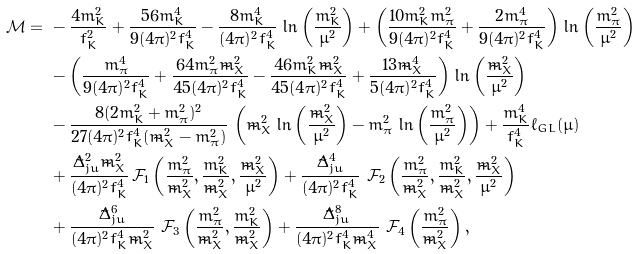<formula> <loc_0><loc_0><loc_500><loc_500>\mathcal { M } = & \ - \frac { 4 m _ { K } ^ { 2 } } { f _ { K } ^ { 2 } } + \frac { 5 6 m _ { K } ^ { 4 } } { 9 ( 4 \pi ) ^ { 2 } f _ { K } ^ { 4 } } - \frac { 8 m _ { K } ^ { 4 } } { ( 4 \pi ) ^ { 2 } f _ { K } ^ { 4 } } \, \ln \left ( \frac { m _ { K } ^ { 2 } } { \mu ^ { 2 } } \right ) + \left ( \frac { 1 0 m _ { K } ^ { 2 } m _ { \pi } ^ { 2 } } { 9 ( 4 \pi ) ^ { 2 } f _ { K } ^ { 4 } } + \frac { 2 m _ { \pi } ^ { 4 } } { 9 ( 4 \pi ) ^ { 2 } f _ { K } ^ { 4 } } \right ) \, \ln \left ( \frac { m _ { \pi } ^ { 2 } } { \mu ^ { 2 } } \right ) \\ & \ - \left ( \frac { m _ { \pi } ^ { 4 } } { 9 ( 4 \pi ) ^ { 2 } f _ { K } ^ { 4 } } + \frac { 6 4 m _ { \pi } ^ { 2 } \tilde { m } _ { X } ^ { 2 } } { 4 5 ( 4 \pi ) ^ { 2 } f _ { K } ^ { 4 } } - \frac { 4 6 m _ { K } ^ { 2 } \tilde { m } _ { X } ^ { 2 } } { 4 5 ( 4 \pi ) ^ { 2 } f _ { K } ^ { 4 } } + \frac { 1 3 \tilde { m } _ { X } ^ { 4 } } { 5 ( 4 \pi ) ^ { 2 } f _ { K } ^ { 4 } } \right ) \, \ln \left ( \frac { \tilde { m } _ { X } ^ { 2 } } { \mu ^ { 2 } } \right ) \\ & \ - \frac { 8 ( 2 m _ { K } ^ { 2 } + m _ { \pi } ^ { 2 } ) ^ { 2 } } { 2 7 ( 4 \pi ) ^ { 2 } f _ { K } ^ { 4 } ( \tilde { m } _ { X } ^ { 2 } - m _ { \pi } ^ { 2 } ) } \, \left ( \tilde { m } _ { X } ^ { 2 } \, \ln \left ( \frac { \tilde { m } _ { X } ^ { 2 } } { \mu ^ { 2 } } \right ) - m _ { \pi } ^ { 2 } \, \ln \left ( \frac { m _ { \pi } ^ { 2 } } { \mu ^ { 2 } } \right ) \right ) + \frac { m _ { K } ^ { 4 } } { f _ { K } ^ { 4 } } \ell _ { G L } ( \mu ) \\ & \ + \frac { \tilde { \Delta } _ { j u } ^ { 2 } \tilde { m } _ { X } ^ { 2 } } { ( 4 \pi ) ^ { 2 } f _ { K } ^ { 4 } } \, \mathcal { F } _ { 1 } \left ( \frac { m _ { \pi } ^ { 2 } } { \tilde { m } _ { X } ^ { 2 } } , \frac { m _ { K } ^ { 2 } } { \tilde { m } _ { X } ^ { 2 } } , \frac { \tilde { m } _ { X } ^ { 2 } } { \mu ^ { 2 } } \right ) + \frac { \tilde { \Delta } _ { j u } ^ { 4 } } { ( 4 \pi ) ^ { 2 } f _ { K } ^ { 4 } } \ \mathcal { F } _ { 2 } \left ( \frac { m _ { \pi } ^ { 2 } } { \tilde { m } _ { X } ^ { 2 } } , \frac { m _ { K } ^ { 2 } } { \tilde { m } _ { X } ^ { 2 } } , \frac { \tilde { m } _ { X } ^ { 2 } } { \mu ^ { 2 } } \right ) \\ & \ + \frac { \tilde { \Delta } _ { j u } ^ { 6 } } { ( 4 \pi ) ^ { 2 } f _ { K } ^ { 4 } \tilde { m } _ { X } ^ { 2 } } \ \mathcal { F } _ { 3 } \left ( \frac { m _ { \pi } ^ { 2 } } { \tilde { m } _ { X } ^ { 2 } } , \frac { m _ { K } ^ { 2 } } { \tilde { m } _ { X } ^ { 2 } } \right ) + \frac { \tilde { \Delta } _ { j u } ^ { 8 } } { ( 4 \pi ) ^ { 2 } f _ { K } ^ { 4 } \tilde { m } _ { X } ^ { 4 } } \ \mathcal { F } _ { 4 } \left ( \frac { m _ { \pi } ^ { 2 } } { \tilde { m } _ { X } ^ { 2 } } \right ) ,</formula> 